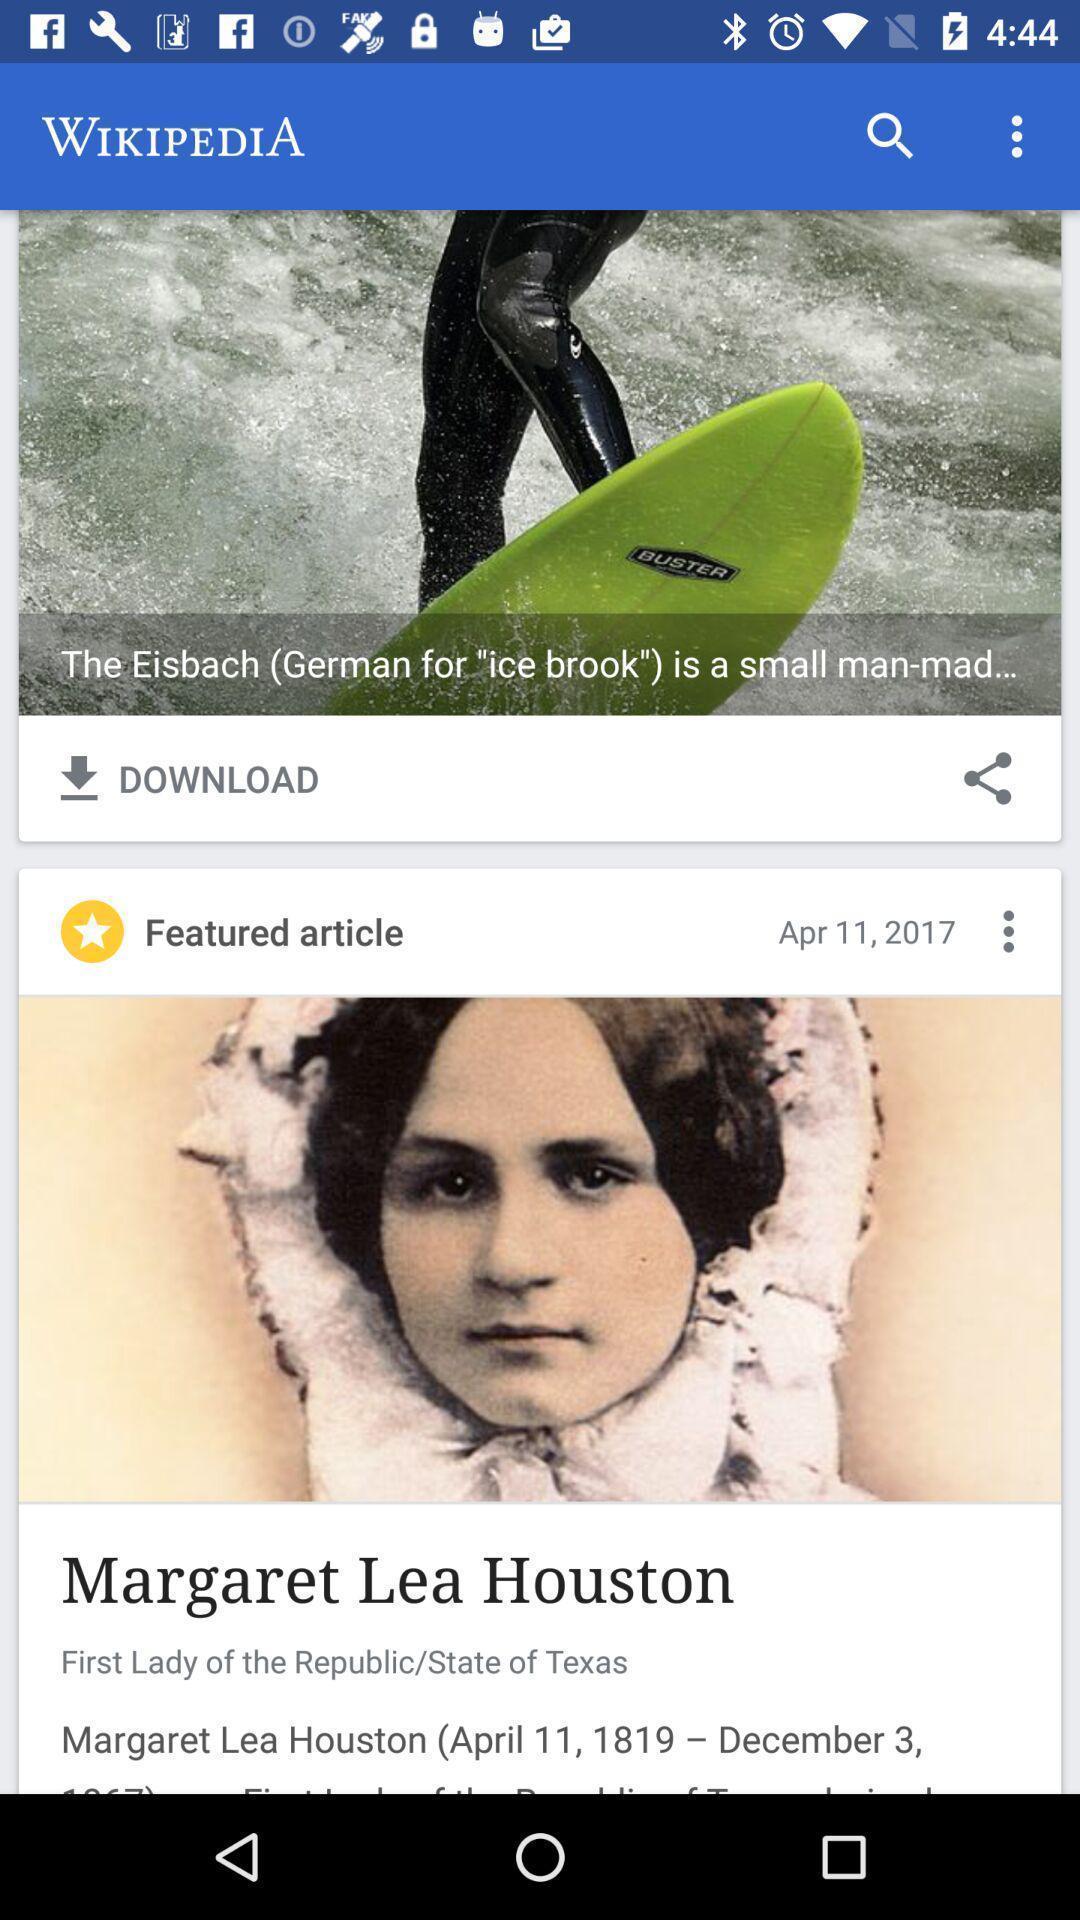Describe the visual elements of this screenshot. Screen displaying various articles in a social app. 